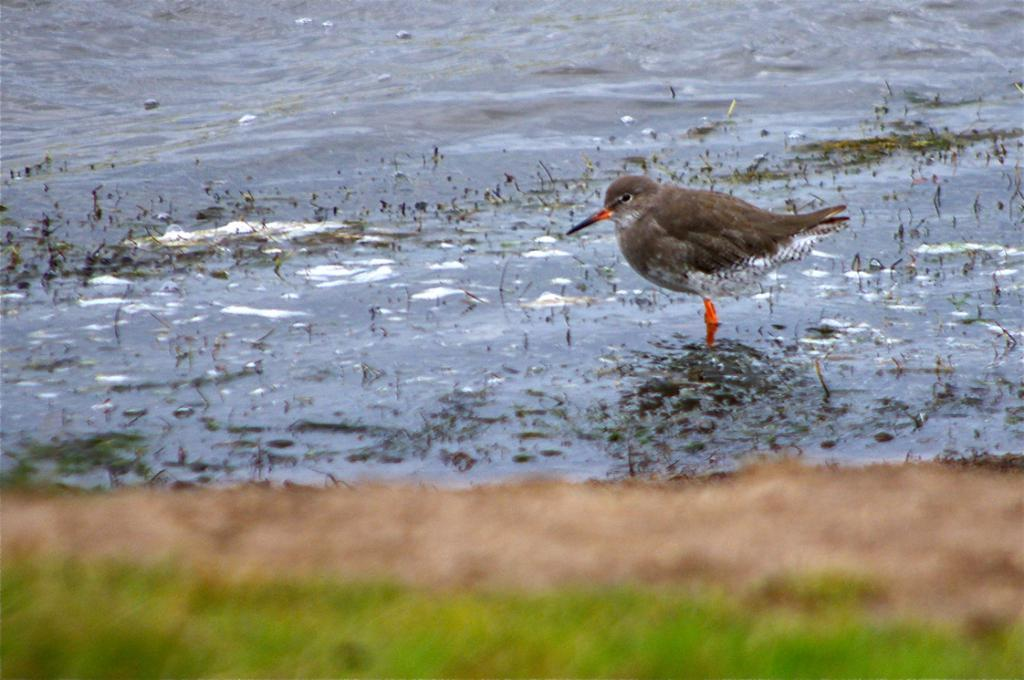What type of animal can be seen in the image? There is a bird in the image. What is the primary element in which the bird is situated? There is water visible in the image, and the bird is situated in it. What is the weight of the bird in the image? The weight of the bird cannot be determined from the image alone, as it depends on the species and size of the bird. 